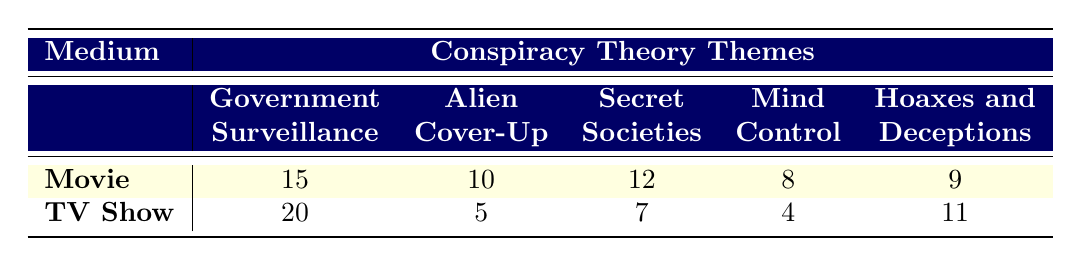What is the frequency of "Government Surveillance" in movies? The table indicates that the frequency of the "Government Surveillance" theme in movies is listed under the "Movie" row, in the "Government Surveillance" column, which shows a value of 15.
Answer: 15 How many conspiracy theory themes are more prevalent in movies than in TV shows? By comparing the frequencies for each theme in both mediums, only the "Government Surveillance" (15 vs 20) and "Alien Cover-Up" (10 vs 5) themes are relevant. The "Government Surveillance" theme is more prevalent in TV shows, while the "Alien Cover-Up" is more prevalent in movies. Since only one theme is identified as more prevalent in movies, that is the total count.
Answer: 1 What is the total frequency of conspiracy theory themes in TV shows? The total frequency for TV shows can be calculated by summing up the frequencies: 20 (Government Surveillance) + 5 (Alien Cover-Up) + 7 (Secret Societies) + 4 (Mind Control) + 11 (Hoaxes and Deceptions) = 47.
Answer: 47 Is "Mind Control" more frequently depicted in movies or TV shows? By checking the values in the table for the "Mind Control" theme under each medium, movies show a frequency of 8 and TV shows display a frequency of 4. Since 8 is greater than 4, "Mind Control" is more frequently depicted in movies.
Answer: Yes What is the difference between the frequency of "Hoaxes and Deceptions" in TV shows and its frequency in movies? The frequency for "Hoaxes and Deceptions" in TV shows is 11 and in movies is 9. To find the difference, we subtract the movie frequency from the TV show frequency: 11 - 9 = 2.
Answer: 2 Which theme has the highest frequency in TV shows? From the TV Show row in the table, the theme with the highest frequency is "Government Surveillance," which has a frequency of 20. To confirm, we can compare it with other themes. No other theme exceeds this value.
Answer: Government Surveillance How many conspiracy themes in movies have a frequency greater than 10? In the movie category, we look for themes with a frequency greater than 10. The themes are "Government Surveillance" (15), "Alien Cover-Up" (10), and "Secret Societies" (12). "Alien Cover-Up" does not qualify. Thus, the qualifying themes are "Government Surveillance" and "Secret Societies," leading to a total count of 2.
Answer: 2 Calculate the average frequency of conspiracy theory themes in movies. The total frequency of the conspiracy theory themes in movies is obtained by adding: 15 (Government Surveillance) + 10 (Alien Cover-Up) + 12 (Secret Societies) + 8 (Mind Control) + 9 (Hoaxes and Deceptions) = 54. There are 5 themes, hence the average is 54 divided by 5, which equals 10.8.
Answer: 10.8 Is the frequency of "Secret Societies" in movies greater than that in TV shows? The movie frequency for "Secret Societies" is 12, and for TV shows, it is 7. Since 12 is greater than 7, this indicates that the frequency of "Secret Societies" is indeed greater in movies.
Answer: Yes 